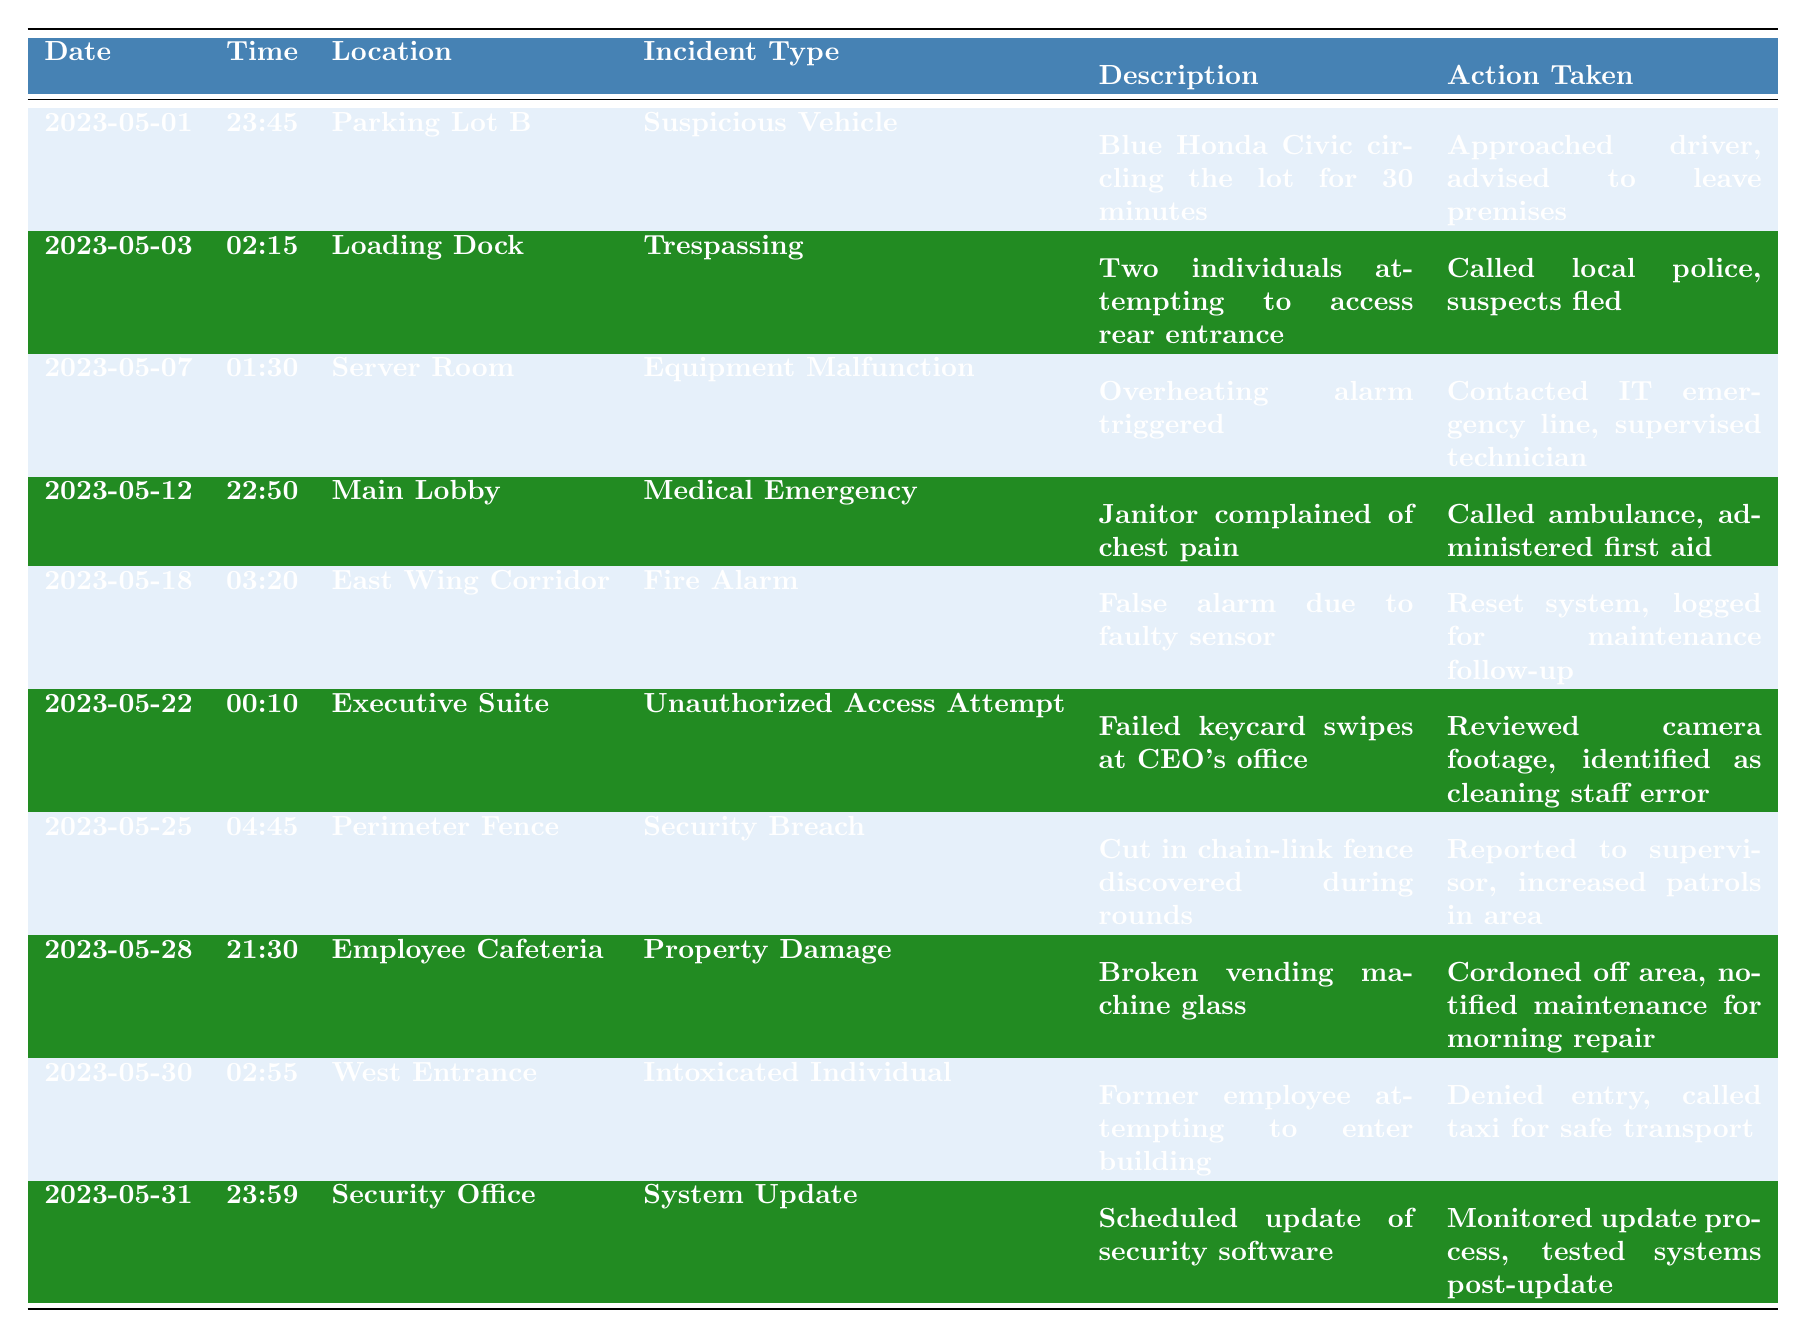What is the date of the incident involving a suspicious vehicle? The table lists various incidents with dates. The entry for "Suspicious Vehicle" is dated "2023-05-01".
Answer: 2023-05-01 How many incidents occurred in the month of May? Counting the entries in the table, there are 10 incidents reported throughout May.
Answer: 10 What action was taken for the medical emergency incident? Referring to the row for "Medical Emergency", the action taken was "Called ambulance, administered first aid".
Answer: Called ambulance, administered first aid Which incident occurred at the West Entrance? The West Entrance incident, which refers to an "Intoxicated Individual", can be found in the table under that location heading.
Answer: Intoxicated Individual What is the incident type that was logged on 2023-05-18? Looking at the entry for that date, the incident type recorded is "Fire Alarm".
Answer: Fire Alarm Was there any report of trespassing in May? Yes, according to the table, there was an incident of trespassing reported on "2023-05-03".
Answer: Yes How many incidents involved security breaches? Checking the table, there is one incident labeled "Security Breach" dated "2023-05-25".
Answer: 1 What was the last incident recorded in the log? The last entry in the table corresponds to the date "2023-05-31". This incident is categorized as a "System Update".
Answer: System Update Which location had the property damage incident? The table indicates that the property damage incident occurred in the "Employee Cafeteria".
Answer: Employee Cafeteria What time did the incident involving unauthorized access attempt occur? The entry for "Unauthorized Access Attempt" lists the time as "00:10".
Answer: 00:10 What incident types were recorded on the same date, May 1 and May 3? On May 1, it was a "Suspicious Vehicle", and on May 3, it was "Trespassing".
Answer: Suspicious Vehicle and Trespassing How long was the suspicious vehicle reported circling the lot? The description for the suspected vehicle states it was circling the lot for "30 minutes".
Answer: 30 minutes Did the incident on May 18 require a police report? The incident on May 18 was a false alarm and did not involve local police, so no report was made.
Answer: No What action was taken regarding the broken vending machine glass? According to the table, the action taken was to "Cordoned off area, notified maintenance for morning repair".
Answer: Cordoned off area, notified maintenance for morning repair How many actions involved contacting another party? The actions involving other parties include calling local police, calling an ambulance, and contacting the IT emergency line, totaling three actions.
Answer: 3 Which incident was categorized under both a medical emergency and required immediate assistance? The "Medical Emergency" incident on May 12 concerning a janitor with chest pain needed immediate assistance.
Answer: Medical Emergency 